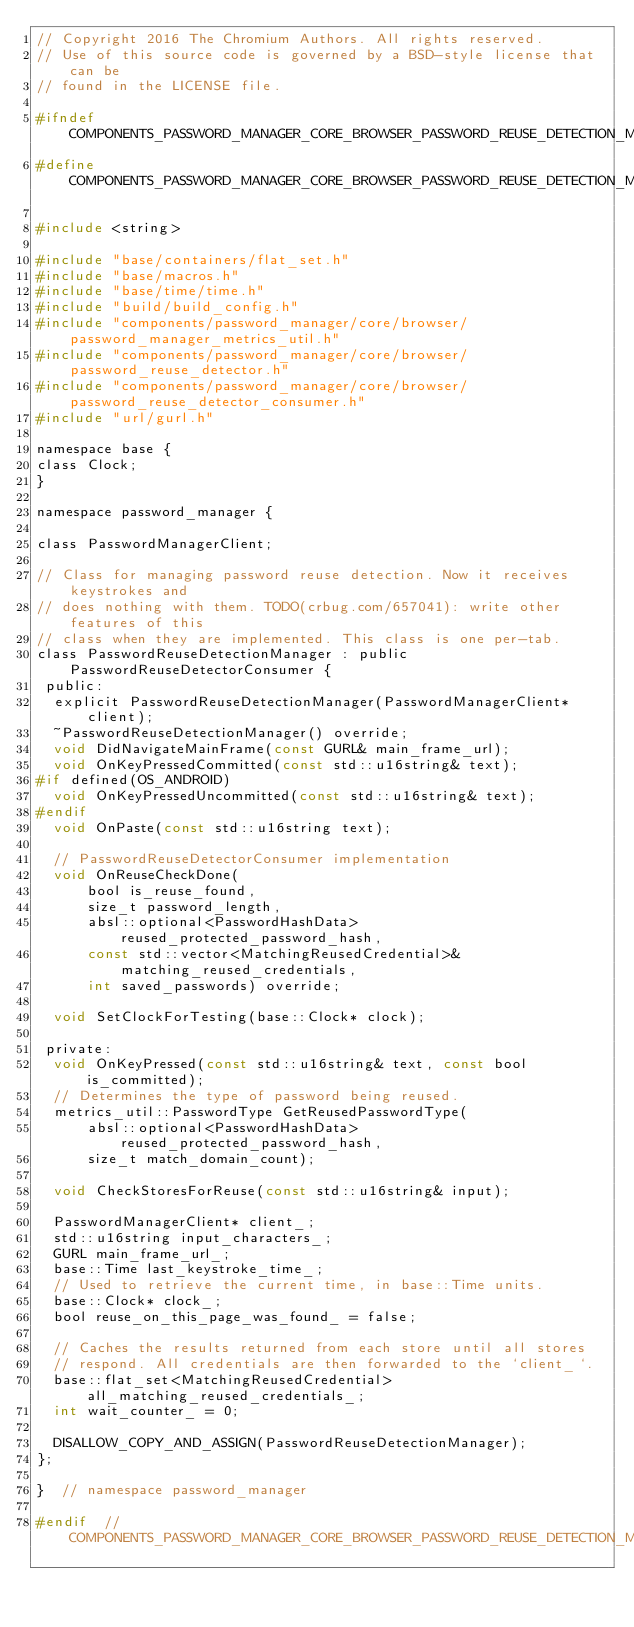<code> <loc_0><loc_0><loc_500><loc_500><_C_>// Copyright 2016 The Chromium Authors. All rights reserved.
// Use of this source code is governed by a BSD-style license that can be
// found in the LICENSE file.

#ifndef COMPONENTS_PASSWORD_MANAGER_CORE_BROWSER_PASSWORD_REUSE_DETECTION_MANAGER_H_
#define COMPONENTS_PASSWORD_MANAGER_CORE_BROWSER_PASSWORD_REUSE_DETECTION_MANAGER_H_

#include <string>

#include "base/containers/flat_set.h"
#include "base/macros.h"
#include "base/time/time.h"
#include "build/build_config.h"
#include "components/password_manager/core/browser/password_manager_metrics_util.h"
#include "components/password_manager/core/browser/password_reuse_detector.h"
#include "components/password_manager/core/browser/password_reuse_detector_consumer.h"
#include "url/gurl.h"

namespace base {
class Clock;
}

namespace password_manager {

class PasswordManagerClient;

// Class for managing password reuse detection. Now it receives keystrokes and
// does nothing with them. TODO(crbug.com/657041): write other features of this
// class when they are implemented. This class is one per-tab.
class PasswordReuseDetectionManager : public PasswordReuseDetectorConsumer {
 public:
  explicit PasswordReuseDetectionManager(PasswordManagerClient* client);
  ~PasswordReuseDetectionManager() override;
  void DidNavigateMainFrame(const GURL& main_frame_url);
  void OnKeyPressedCommitted(const std::u16string& text);
#if defined(OS_ANDROID)
  void OnKeyPressedUncommitted(const std::u16string& text);
#endif
  void OnPaste(const std::u16string text);

  // PasswordReuseDetectorConsumer implementation
  void OnReuseCheckDone(
      bool is_reuse_found,
      size_t password_length,
      absl::optional<PasswordHashData> reused_protected_password_hash,
      const std::vector<MatchingReusedCredential>& matching_reused_credentials,
      int saved_passwords) override;

  void SetClockForTesting(base::Clock* clock);

 private:
  void OnKeyPressed(const std::u16string& text, const bool is_committed);
  // Determines the type of password being reused.
  metrics_util::PasswordType GetReusedPasswordType(
      absl::optional<PasswordHashData> reused_protected_password_hash,
      size_t match_domain_count);

  void CheckStoresForReuse(const std::u16string& input);

  PasswordManagerClient* client_;
  std::u16string input_characters_;
  GURL main_frame_url_;
  base::Time last_keystroke_time_;
  // Used to retrieve the current time, in base::Time units.
  base::Clock* clock_;
  bool reuse_on_this_page_was_found_ = false;

  // Caches the results returned from each store until all stores
  // respond. All credentials are then forwarded to the `client_`.
  base::flat_set<MatchingReusedCredential> all_matching_reused_credentials_;
  int wait_counter_ = 0;

  DISALLOW_COPY_AND_ASSIGN(PasswordReuseDetectionManager);
};

}  // namespace password_manager

#endif  // COMPONENTS_PASSWORD_MANAGER_CORE_BROWSER_PASSWORD_REUSE_DETECTION_MANAGER_H_
</code> 